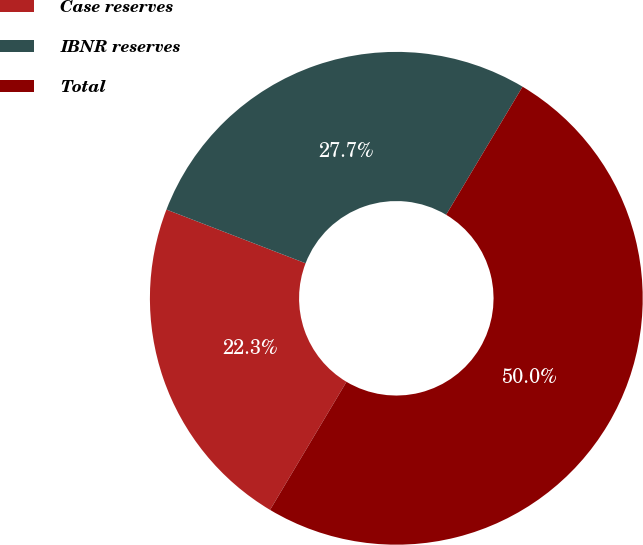Convert chart to OTSL. <chart><loc_0><loc_0><loc_500><loc_500><pie_chart><fcel>Case reserves<fcel>IBNR reserves<fcel>Total<nl><fcel>22.3%<fcel>27.7%<fcel>50.0%<nl></chart> 